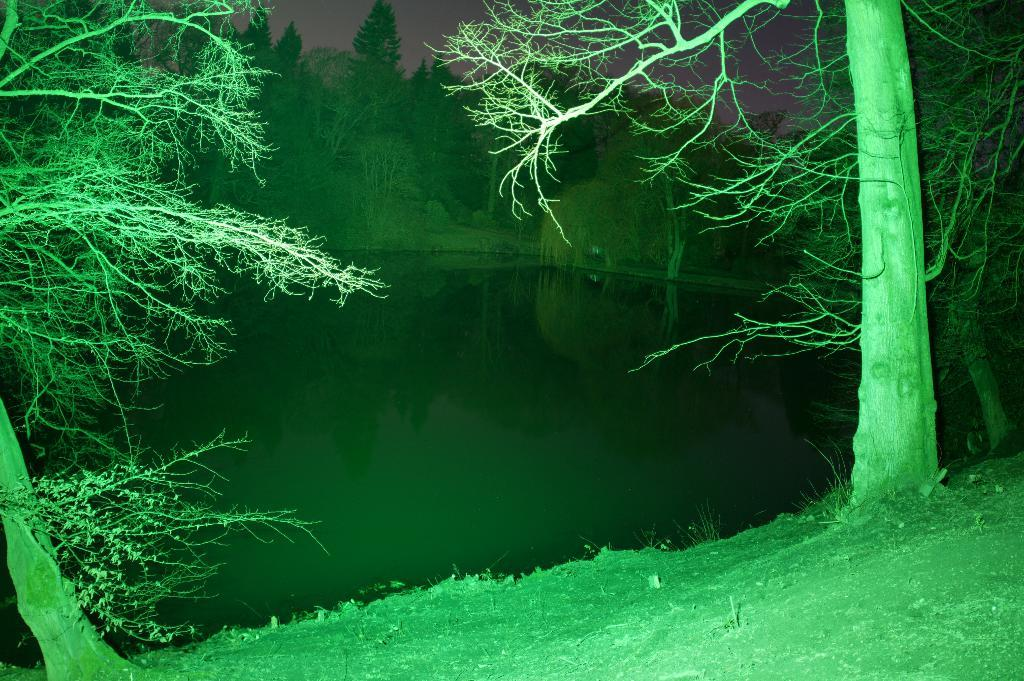What is one of the natural elements present in the image? There is water in the image. What type of vegetation can be seen in the image? There is grass and trees in the image. Where are the trees located in the image? There are trees in both the foreground and background of the image. What is visible in the background of the image? The sky is visible in the image. How many roses can be seen growing in the grass in the image? There are no roses visible in the image; only grass and trees are present. What type of activity is taking place during the recess in the image? There is no indication of a recess or any activity taking place in the image. 